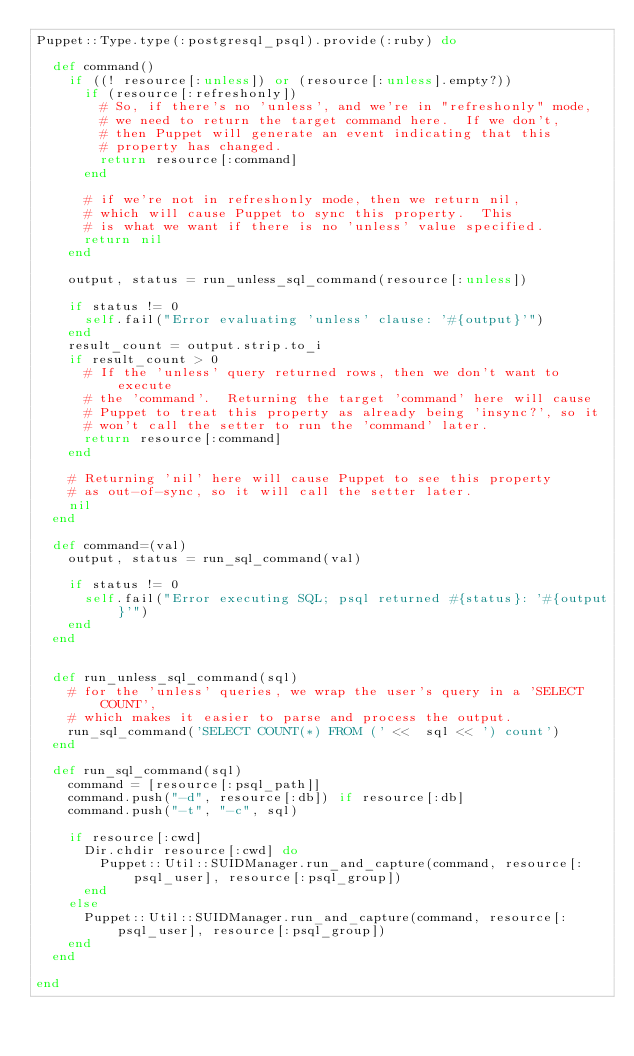<code> <loc_0><loc_0><loc_500><loc_500><_Ruby_>Puppet::Type.type(:postgresql_psql).provide(:ruby) do

  def command()
    if ((! resource[:unless]) or (resource[:unless].empty?))
      if (resource[:refreshonly])
        # So, if there's no 'unless', and we're in "refreshonly" mode,
        # we need to return the target command here.  If we don't,
        # then Puppet will generate an event indicating that this
        # property has changed.
        return resource[:command]
      end

      # if we're not in refreshonly mode, then we return nil,
      # which will cause Puppet to sync this property.  This
      # is what we want if there is no 'unless' value specified.
      return nil
    end

    output, status = run_unless_sql_command(resource[:unless])

    if status != 0
      self.fail("Error evaluating 'unless' clause: '#{output}'")
    end
    result_count = output.strip.to_i
    if result_count > 0
      # If the 'unless' query returned rows, then we don't want to execute
      # the 'command'.  Returning the target 'command' here will cause
      # Puppet to treat this property as already being 'insync?', so it
      # won't call the setter to run the 'command' later.
      return resource[:command]
    end

    # Returning 'nil' here will cause Puppet to see this property
    # as out-of-sync, so it will call the setter later.
    nil
  end

  def command=(val)
    output, status = run_sql_command(val)

    if status != 0
      self.fail("Error executing SQL; psql returned #{status}: '#{output}'")
    end
  end


  def run_unless_sql_command(sql)
    # for the 'unless' queries, we wrap the user's query in a 'SELECT COUNT',
    # which makes it easier to parse and process the output.
    run_sql_command('SELECT COUNT(*) FROM (' <<  sql << ') count')
  end

  def run_sql_command(sql)
    command = [resource[:psql_path]]
    command.push("-d", resource[:db]) if resource[:db]
    command.push("-t", "-c", sql)

    if resource[:cwd]
      Dir.chdir resource[:cwd] do
        Puppet::Util::SUIDManager.run_and_capture(command, resource[:psql_user], resource[:psql_group])
      end
    else
      Puppet::Util::SUIDManager.run_and_capture(command, resource[:psql_user], resource[:psql_group])
    end
  end

end
</code> 